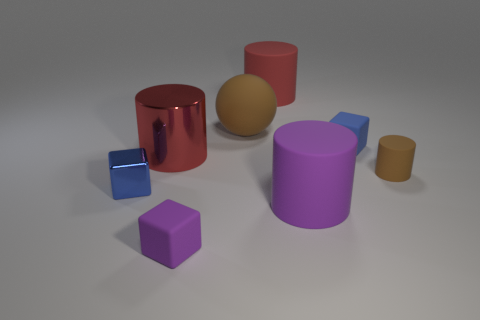There is a red cylinder that is made of the same material as the big brown object; what is its size?
Your answer should be very brief. Large. What number of tiny things are in front of the tiny matte cylinder and right of the blue metallic cube?
Ensure brevity in your answer.  1. How many objects are big yellow metallic cylinders or purple rubber things right of the purple matte block?
Give a very brief answer. 1. There is a object that is the same color as the rubber sphere; what shape is it?
Ensure brevity in your answer.  Cylinder. There is a big matte cylinder in front of the large red matte thing; what color is it?
Provide a short and direct response. Purple. What number of objects are either large red things in front of the tiny blue rubber cube or metal cylinders?
Your answer should be compact. 1. What color is the other matte block that is the same size as the purple rubber block?
Provide a succinct answer. Blue. Are there more tiny blue shiny cubes to the left of the purple cube than large cyan matte cylinders?
Your answer should be compact. Yes. What material is the small thing that is both behind the small purple matte block and left of the red matte cylinder?
Provide a succinct answer. Metal. Is the color of the block that is left of the large metal cylinder the same as the small block behind the small blue metallic block?
Give a very brief answer. Yes. 